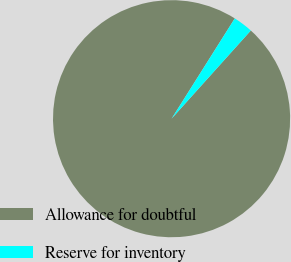Convert chart to OTSL. <chart><loc_0><loc_0><loc_500><loc_500><pie_chart><fcel>Allowance for doubtful<fcel>Reserve for inventory<nl><fcel>97.3%<fcel>2.7%<nl></chart> 